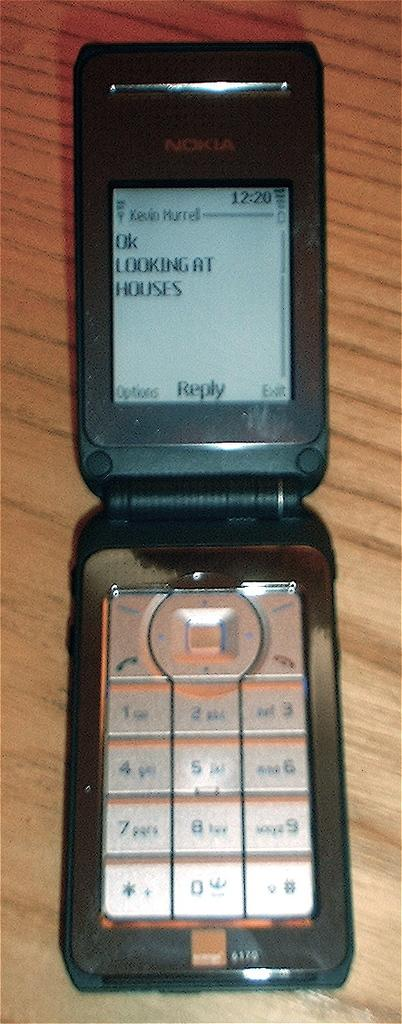What is the main subject of the image? The main subject of the image is a mobile. Where is the mobile located in the image? The mobile is on a platform. What can be seen on the mobile's screen? There is a message visible on the mobile's screen. What type of crush can be seen happening in the image? There is no crush present in the image; it features a mobile on a platform with a message on its screen. What part of the mobile is responsible for stopping the message from appearing? The image does not show any mechanism or part responsible for stopping the message from appearing on the mobile's screen. 